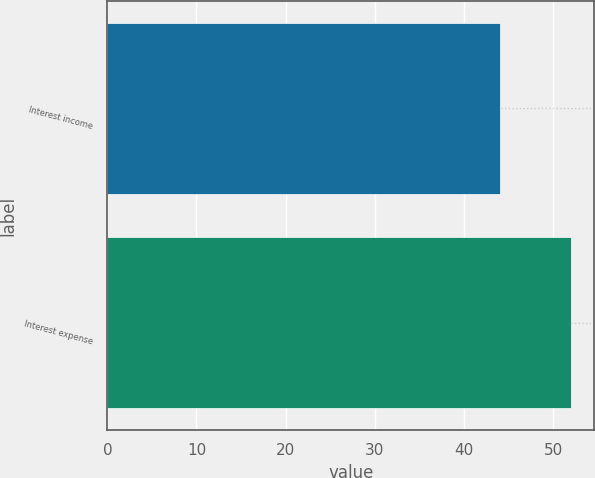Convert chart to OTSL. <chart><loc_0><loc_0><loc_500><loc_500><bar_chart><fcel>Interest income<fcel>Interest expense<nl><fcel>44<fcel>52<nl></chart> 